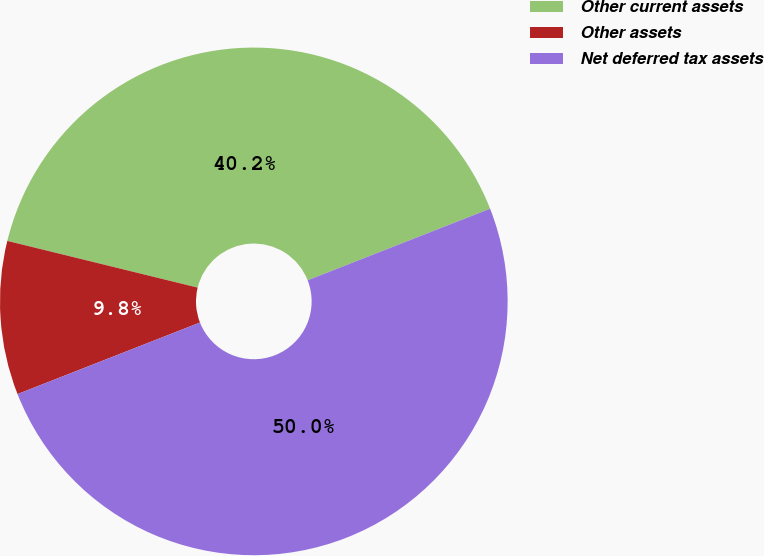<chart> <loc_0><loc_0><loc_500><loc_500><pie_chart><fcel>Other current assets<fcel>Other assets<fcel>Net deferred tax assets<nl><fcel>40.22%<fcel>9.78%<fcel>50.0%<nl></chart> 